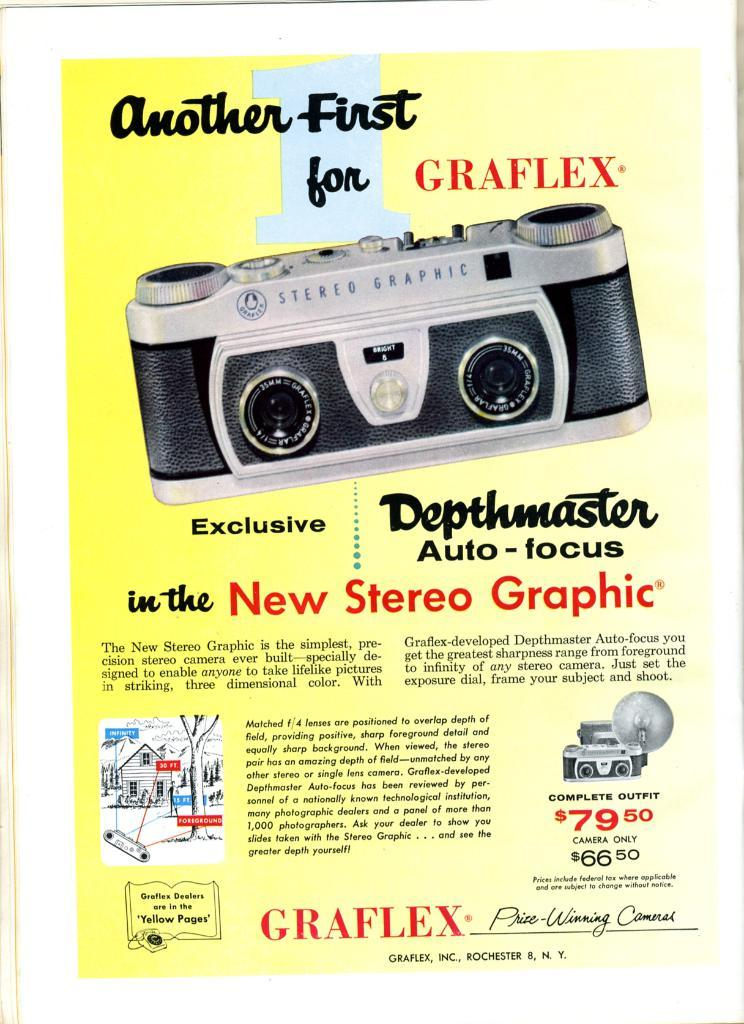What type of content is featured in the image? The image is an edited advertisement page. What is being advertised on the page? The advertisement is for a device. What is the name of the device being advertised? The name of the device is mentioned on the page. How much does the device cost? The cost of the device is mentioned on the page. Can you describe the waves in the image? There are no waves present in the image; it is an edited advertisement page for a device. 